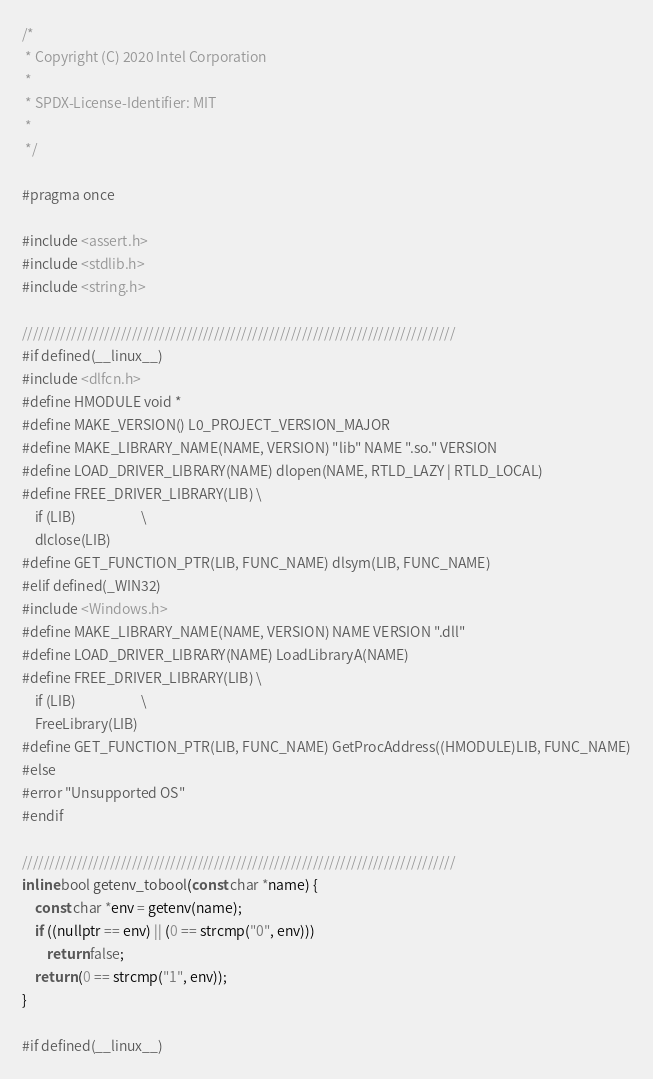Convert code to text. <code><loc_0><loc_0><loc_500><loc_500><_C_>/*
 * Copyright (C) 2020 Intel Corporation
 *
 * SPDX-License-Identifier: MIT
 *
 */

#pragma once

#include <assert.h>
#include <stdlib.h>
#include <string.h>

///////////////////////////////////////////////////////////////////////////////
#if defined(__linux__)
#include <dlfcn.h>
#define HMODULE void *
#define MAKE_VERSION() L0_PROJECT_VERSION_MAJOR
#define MAKE_LIBRARY_NAME(NAME, VERSION) "lib" NAME ".so." VERSION
#define LOAD_DRIVER_LIBRARY(NAME) dlopen(NAME, RTLD_LAZY | RTLD_LOCAL)
#define FREE_DRIVER_LIBRARY(LIB) \
    if (LIB)                     \
    dlclose(LIB)
#define GET_FUNCTION_PTR(LIB, FUNC_NAME) dlsym(LIB, FUNC_NAME)
#elif defined(_WIN32)
#include <Windows.h>
#define MAKE_LIBRARY_NAME(NAME, VERSION) NAME VERSION ".dll"
#define LOAD_DRIVER_LIBRARY(NAME) LoadLibraryA(NAME)
#define FREE_DRIVER_LIBRARY(LIB) \
    if (LIB)                     \
    FreeLibrary(LIB)
#define GET_FUNCTION_PTR(LIB, FUNC_NAME) GetProcAddress((HMODULE)LIB, FUNC_NAME)
#else
#error "Unsupported OS"
#endif

///////////////////////////////////////////////////////////////////////////////
inline bool getenv_tobool(const char *name) {
    const char *env = getenv(name);
    if ((nullptr == env) || (0 == strcmp("0", env)))
        return false;
    return (0 == strcmp("1", env));
}

#if defined(__linux__)</code> 